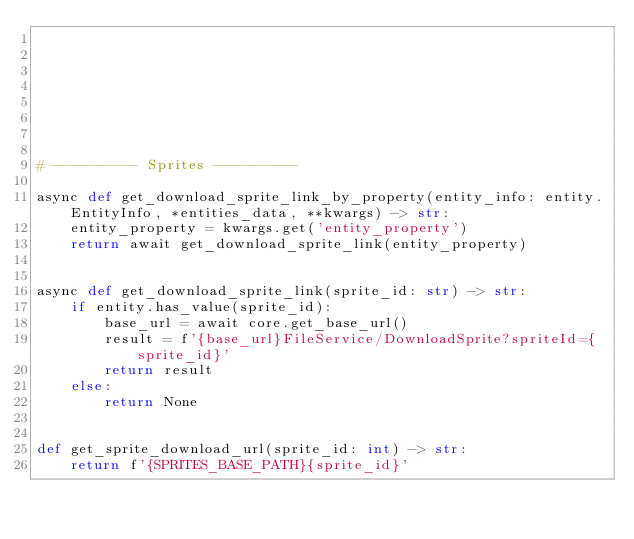Convert code to text. <code><loc_0><loc_0><loc_500><loc_500><_Python_>







# ---------- Sprites ----------

async def get_download_sprite_link_by_property(entity_info: entity.EntityInfo, *entities_data, **kwargs) -> str:
    entity_property = kwargs.get('entity_property')
    return await get_download_sprite_link(entity_property)


async def get_download_sprite_link(sprite_id: str) -> str:
    if entity.has_value(sprite_id):
        base_url = await core.get_base_url()
        result = f'{base_url}FileService/DownloadSprite?spriteId={sprite_id}'
        return result
    else:
        return None


def get_sprite_download_url(sprite_id: int) -> str:
    return f'{SPRITES_BASE_PATH}{sprite_id}'
</code> 